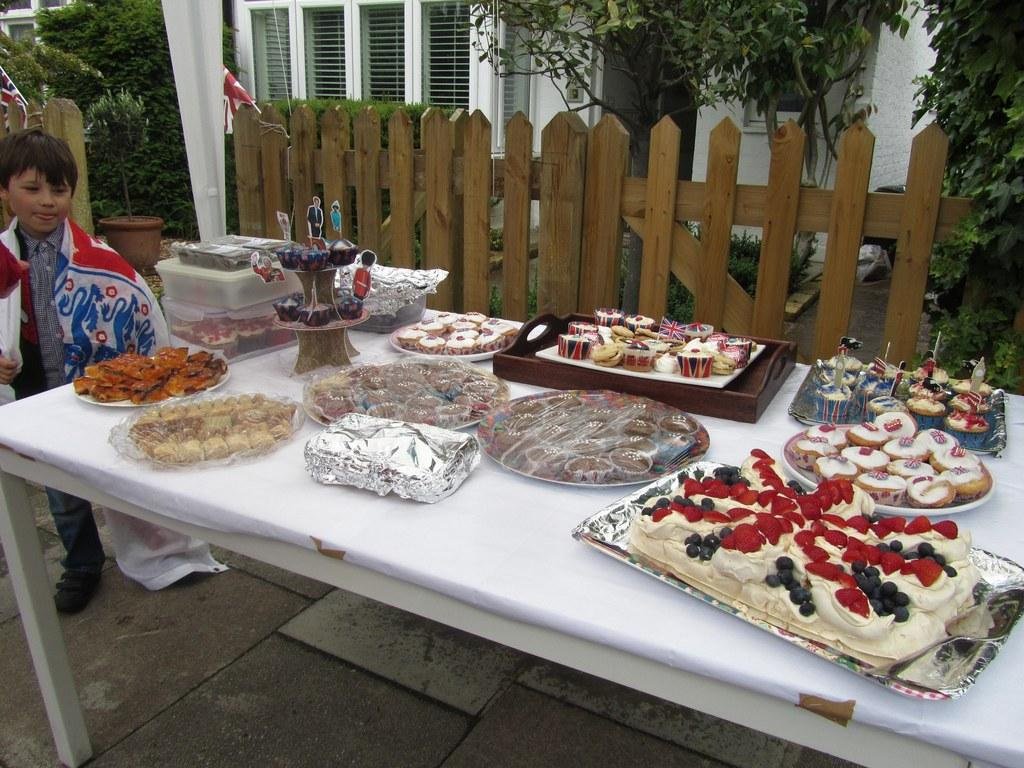What is the boy doing in the image? The boy is standing on the ground in front of a table. What can be seen on the table in the image? There are objects on the table. What type of barrier is present in the image? There is a fence in the image. What type of vegetation is near the house in the image? There are trees beside the house in the image. What type of fact is being discussed in the image? There is no discussion of a fact in the image; it is a visual representation of a scene. 